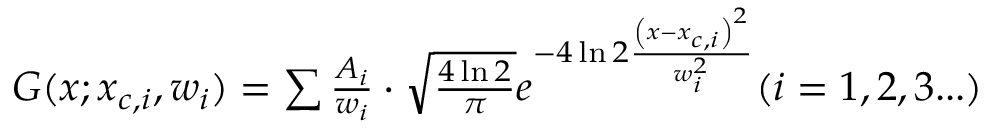<formula> <loc_0><loc_0><loc_500><loc_500>\begin{array} { r } { G ( x ; x _ { c , i } , w _ { i } ) = \sum \frac { A _ { i } } { w _ { i } } \cdot \sqrt { \frac { 4 \ln 2 } { \pi } } e ^ { { - 4 \ln 2 } \frac { \left ( x - x _ { c , i } \right ) ^ { 2 } } { w _ { i } ^ { 2 } } } ( i = 1 , 2 , 3 \dots ) } \end{array}</formula> 